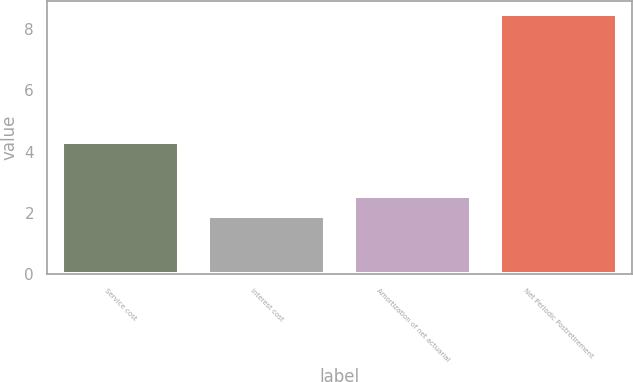<chart> <loc_0><loc_0><loc_500><loc_500><bar_chart><fcel>Service cost<fcel>Interest cost<fcel>Amortization of net actuarial<fcel>Net Periodic Postretirement<nl><fcel>4.3<fcel>1.9<fcel>2.56<fcel>8.5<nl></chart> 